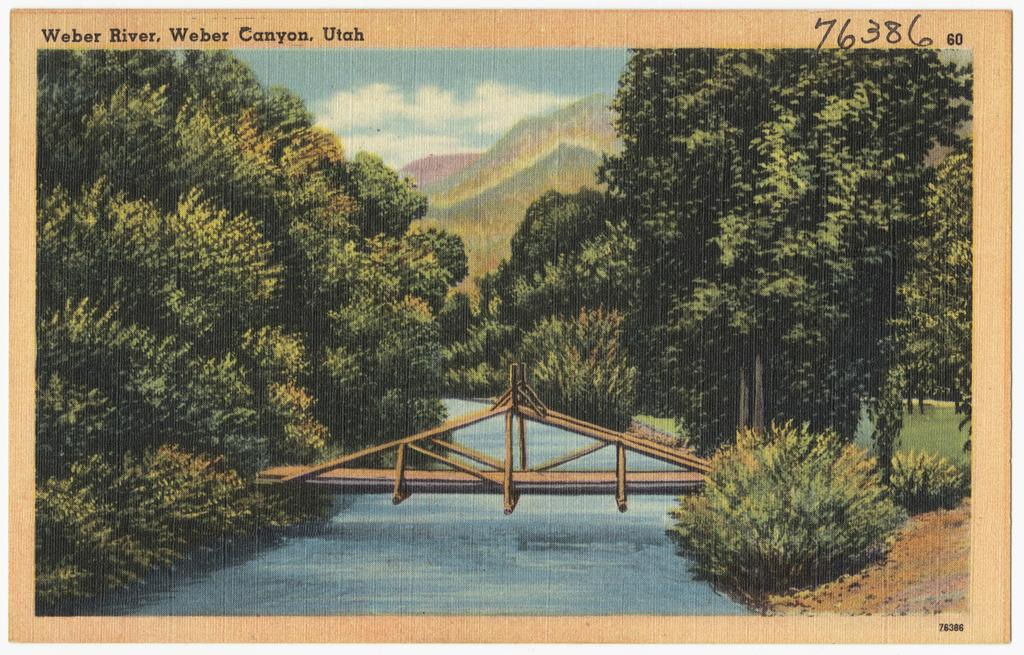What structure can be seen in the image? There is a bridge in the image. What natural element is visible in the image? There is water visible in the image. What type of vegetation can be seen in the image? There are plants and trees in the image. What part of the natural environment is visible in the image? The sky is visible in the image. Are there any written elements in the image? Yes, there are words and numbers written in the image. What type of heat can be felt coming from the bridge in the image? There is no indication of heat or temperature in the image, and therefore it cannot be determined from the image. 